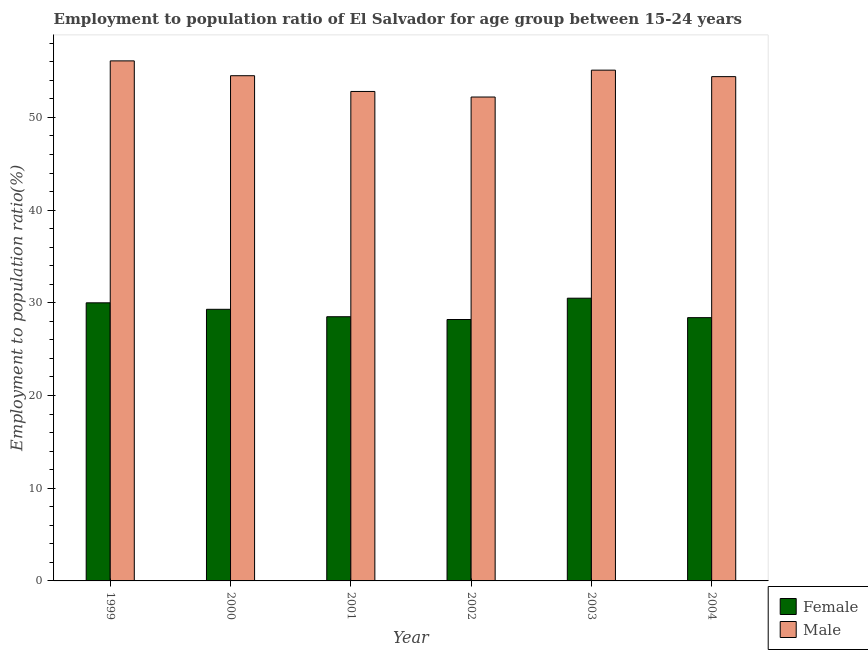Are the number of bars on each tick of the X-axis equal?
Your response must be concise. Yes. How many bars are there on the 1st tick from the right?
Make the answer very short. 2. What is the label of the 5th group of bars from the left?
Keep it short and to the point. 2003. In how many cases, is the number of bars for a given year not equal to the number of legend labels?
Your answer should be very brief. 0. What is the employment to population ratio(male) in 2002?
Provide a succinct answer. 52.2. Across all years, what is the maximum employment to population ratio(female)?
Keep it short and to the point. 30.5. Across all years, what is the minimum employment to population ratio(female)?
Keep it short and to the point. 28.2. In which year was the employment to population ratio(male) minimum?
Provide a short and direct response. 2002. What is the total employment to population ratio(female) in the graph?
Offer a very short reply. 174.9. What is the difference between the employment to population ratio(male) in 2000 and that in 2001?
Keep it short and to the point. 1.7. What is the difference between the employment to population ratio(male) in 2001 and the employment to population ratio(female) in 2003?
Offer a very short reply. -2.3. What is the average employment to population ratio(female) per year?
Offer a terse response. 29.15. In how many years, is the employment to population ratio(female) greater than 36 %?
Ensure brevity in your answer.  0. What is the ratio of the employment to population ratio(female) in 2000 to that in 2003?
Keep it short and to the point. 0.96. Is the employment to population ratio(female) in 1999 less than that in 2000?
Offer a terse response. No. Is the difference between the employment to population ratio(female) in 1999 and 2001 greater than the difference between the employment to population ratio(male) in 1999 and 2001?
Keep it short and to the point. No. What is the difference between the highest and the second highest employment to population ratio(female)?
Keep it short and to the point. 0.5. What is the difference between the highest and the lowest employment to population ratio(male)?
Provide a succinct answer. 3.9. Is the sum of the employment to population ratio(female) in 2001 and 2002 greater than the maximum employment to population ratio(male) across all years?
Your answer should be very brief. Yes. What does the 2nd bar from the left in 2003 represents?
Your answer should be very brief. Male. What does the 2nd bar from the right in 2002 represents?
Offer a very short reply. Female. Does the graph contain any zero values?
Provide a succinct answer. No. Does the graph contain grids?
Offer a very short reply. No. Where does the legend appear in the graph?
Offer a very short reply. Bottom right. How many legend labels are there?
Ensure brevity in your answer.  2. What is the title of the graph?
Provide a succinct answer. Employment to population ratio of El Salvador for age group between 15-24 years. What is the label or title of the X-axis?
Ensure brevity in your answer.  Year. What is the label or title of the Y-axis?
Offer a terse response. Employment to population ratio(%). What is the Employment to population ratio(%) in Female in 1999?
Your answer should be compact. 30. What is the Employment to population ratio(%) of Male in 1999?
Offer a terse response. 56.1. What is the Employment to population ratio(%) of Female in 2000?
Make the answer very short. 29.3. What is the Employment to population ratio(%) of Male in 2000?
Your response must be concise. 54.5. What is the Employment to population ratio(%) of Male in 2001?
Keep it short and to the point. 52.8. What is the Employment to population ratio(%) in Female in 2002?
Your answer should be compact. 28.2. What is the Employment to population ratio(%) of Male in 2002?
Keep it short and to the point. 52.2. What is the Employment to population ratio(%) of Female in 2003?
Offer a very short reply. 30.5. What is the Employment to population ratio(%) in Male in 2003?
Make the answer very short. 55.1. What is the Employment to population ratio(%) of Female in 2004?
Provide a short and direct response. 28.4. What is the Employment to population ratio(%) of Male in 2004?
Offer a very short reply. 54.4. Across all years, what is the maximum Employment to population ratio(%) in Female?
Keep it short and to the point. 30.5. Across all years, what is the maximum Employment to population ratio(%) of Male?
Your answer should be compact. 56.1. Across all years, what is the minimum Employment to population ratio(%) in Female?
Offer a very short reply. 28.2. Across all years, what is the minimum Employment to population ratio(%) in Male?
Make the answer very short. 52.2. What is the total Employment to population ratio(%) of Female in the graph?
Your response must be concise. 174.9. What is the total Employment to population ratio(%) of Male in the graph?
Give a very brief answer. 325.1. What is the difference between the Employment to population ratio(%) of Female in 1999 and that in 2000?
Offer a terse response. 0.7. What is the difference between the Employment to population ratio(%) in Male in 1999 and that in 2000?
Your answer should be very brief. 1.6. What is the difference between the Employment to population ratio(%) of Female in 1999 and that in 2001?
Your response must be concise. 1.5. What is the difference between the Employment to population ratio(%) in Female in 1999 and that in 2002?
Make the answer very short. 1.8. What is the difference between the Employment to population ratio(%) of Male in 1999 and that in 2002?
Your answer should be compact. 3.9. What is the difference between the Employment to population ratio(%) of Female in 1999 and that in 2003?
Provide a short and direct response. -0.5. What is the difference between the Employment to population ratio(%) in Male in 1999 and that in 2003?
Give a very brief answer. 1. What is the difference between the Employment to population ratio(%) of Male in 1999 and that in 2004?
Your answer should be compact. 1.7. What is the difference between the Employment to population ratio(%) of Male in 2000 and that in 2001?
Keep it short and to the point. 1.7. What is the difference between the Employment to population ratio(%) of Female in 2000 and that in 2002?
Keep it short and to the point. 1.1. What is the difference between the Employment to population ratio(%) in Male in 2000 and that in 2002?
Your answer should be very brief. 2.3. What is the difference between the Employment to population ratio(%) in Female in 2000 and that in 2003?
Give a very brief answer. -1.2. What is the difference between the Employment to population ratio(%) in Male in 2000 and that in 2003?
Your answer should be compact. -0.6. What is the difference between the Employment to population ratio(%) in Female in 2000 and that in 2004?
Provide a succinct answer. 0.9. What is the difference between the Employment to population ratio(%) in Female in 2001 and that in 2004?
Ensure brevity in your answer.  0.1. What is the difference between the Employment to population ratio(%) in Male in 2001 and that in 2004?
Offer a terse response. -1.6. What is the difference between the Employment to population ratio(%) of Female in 1999 and the Employment to population ratio(%) of Male in 2000?
Give a very brief answer. -24.5. What is the difference between the Employment to population ratio(%) of Female in 1999 and the Employment to population ratio(%) of Male in 2001?
Ensure brevity in your answer.  -22.8. What is the difference between the Employment to population ratio(%) in Female in 1999 and the Employment to population ratio(%) in Male in 2002?
Give a very brief answer. -22.2. What is the difference between the Employment to population ratio(%) in Female in 1999 and the Employment to population ratio(%) in Male in 2003?
Your answer should be compact. -25.1. What is the difference between the Employment to population ratio(%) in Female in 1999 and the Employment to population ratio(%) in Male in 2004?
Offer a terse response. -24.4. What is the difference between the Employment to population ratio(%) of Female in 2000 and the Employment to population ratio(%) of Male in 2001?
Ensure brevity in your answer.  -23.5. What is the difference between the Employment to population ratio(%) of Female in 2000 and the Employment to population ratio(%) of Male in 2002?
Give a very brief answer. -22.9. What is the difference between the Employment to population ratio(%) in Female in 2000 and the Employment to population ratio(%) in Male in 2003?
Your response must be concise. -25.8. What is the difference between the Employment to population ratio(%) of Female in 2000 and the Employment to population ratio(%) of Male in 2004?
Provide a short and direct response. -25.1. What is the difference between the Employment to population ratio(%) of Female in 2001 and the Employment to population ratio(%) of Male in 2002?
Your answer should be very brief. -23.7. What is the difference between the Employment to population ratio(%) in Female in 2001 and the Employment to population ratio(%) in Male in 2003?
Your response must be concise. -26.6. What is the difference between the Employment to population ratio(%) of Female in 2001 and the Employment to population ratio(%) of Male in 2004?
Your answer should be very brief. -25.9. What is the difference between the Employment to population ratio(%) of Female in 2002 and the Employment to population ratio(%) of Male in 2003?
Your answer should be very brief. -26.9. What is the difference between the Employment to population ratio(%) of Female in 2002 and the Employment to population ratio(%) of Male in 2004?
Your answer should be very brief. -26.2. What is the difference between the Employment to population ratio(%) in Female in 2003 and the Employment to population ratio(%) in Male in 2004?
Offer a very short reply. -23.9. What is the average Employment to population ratio(%) of Female per year?
Provide a succinct answer. 29.15. What is the average Employment to population ratio(%) of Male per year?
Provide a short and direct response. 54.18. In the year 1999, what is the difference between the Employment to population ratio(%) in Female and Employment to population ratio(%) in Male?
Make the answer very short. -26.1. In the year 2000, what is the difference between the Employment to population ratio(%) in Female and Employment to population ratio(%) in Male?
Your response must be concise. -25.2. In the year 2001, what is the difference between the Employment to population ratio(%) in Female and Employment to population ratio(%) in Male?
Your response must be concise. -24.3. In the year 2003, what is the difference between the Employment to population ratio(%) in Female and Employment to population ratio(%) in Male?
Provide a short and direct response. -24.6. In the year 2004, what is the difference between the Employment to population ratio(%) in Female and Employment to population ratio(%) in Male?
Your answer should be very brief. -26. What is the ratio of the Employment to population ratio(%) in Female in 1999 to that in 2000?
Give a very brief answer. 1.02. What is the ratio of the Employment to population ratio(%) in Male in 1999 to that in 2000?
Provide a short and direct response. 1.03. What is the ratio of the Employment to population ratio(%) of Female in 1999 to that in 2001?
Your answer should be very brief. 1.05. What is the ratio of the Employment to population ratio(%) of Female in 1999 to that in 2002?
Your answer should be compact. 1.06. What is the ratio of the Employment to population ratio(%) of Male in 1999 to that in 2002?
Ensure brevity in your answer.  1.07. What is the ratio of the Employment to population ratio(%) in Female in 1999 to that in 2003?
Provide a succinct answer. 0.98. What is the ratio of the Employment to population ratio(%) of Male in 1999 to that in 2003?
Provide a short and direct response. 1.02. What is the ratio of the Employment to population ratio(%) in Female in 1999 to that in 2004?
Make the answer very short. 1.06. What is the ratio of the Employment to population ratio(%) in Male in 1999 to that in 2004?
Offer a very short reply. 1.03. What is the ratio of the Employment to population ratio(%) of Female in 2000 to that in 2001?
Your answer should be compact. 1.03. What is the ratio of the Employment to population ratio(%) in Male in 2000 to that in 2001?
Keep it short and to the point. 1.03. What is the ratio of the Employment to population ratio(%) of Female in 2000 to that in 2002?
Your answer should be compact. 1.04. What is the ratio of the Employment to population ratio(%) in Male in 2000 to that in 2002?
Give a very brief answer. 1.04. What is the ratio of the Employment to population ratio(%) of Female in 2000 to that in 2003?
Your answer should be compact. 0.96. What is the ratio of the Employment to population ratio(%) of Male in 2000 to that in 2003?
Your response must be concise. 0.99. What is the ratio of the Employment to population ratio(%) of Female in 2000 to that in 2004?
Provide a succinct answer. 1.03. What is the ratio of the Employment to population ratio(%) in Male in 2000 to that in 2004?
Give a very brief answer. 1. What is the ratio of the Employment to population ratio(%) in Female in 2001 to that in 2002?
Offer a terse response. 1.01. What is the ratio of the Employment to population ratio(%) in Male in 2001 to that in 2002?
Offer a terse response. 1.01. What is the ratio of the Employment to population ratio(%) in Female in 2001 to that in 2003?
Ensure brevity in your answer.  0.93. What is the ratio of the Employment to population ratio(%) of Male in 2001 to that in 2004?
Keep it short and to the point. 0.97. What is the ratio of the Employment to population ratio(%) of Female in 2002 to that in 2003?
Your response must be concise. 0.92. What is the ratio of the Employment to population ratio(%) in Male in 2002 to that in 2003?
Ensure brevity in your answer.  0.95. What is the ratio of the Employment to population ratio(%) of Female in 2002 to that in 2004?
Give a very brief answer. 0.99. What is the ratio of the Employment to population ratio(%) of Male in 2002 to that in 2004?
Provide a succinct answer. 0.96. What is the ratio of the Employment to population ratio(%) in Female in 2003 to that in 2004?
Make the answer very short. 1.07. What is the ratio of the Employment to population ratio(%) in Male in 2003 to that in 2004?
Keep it short and to the point. 1.01. What is the difference between the highest and the second highest Employment to population ratio(%) in Female?
Make the answer very short. 0.5. 